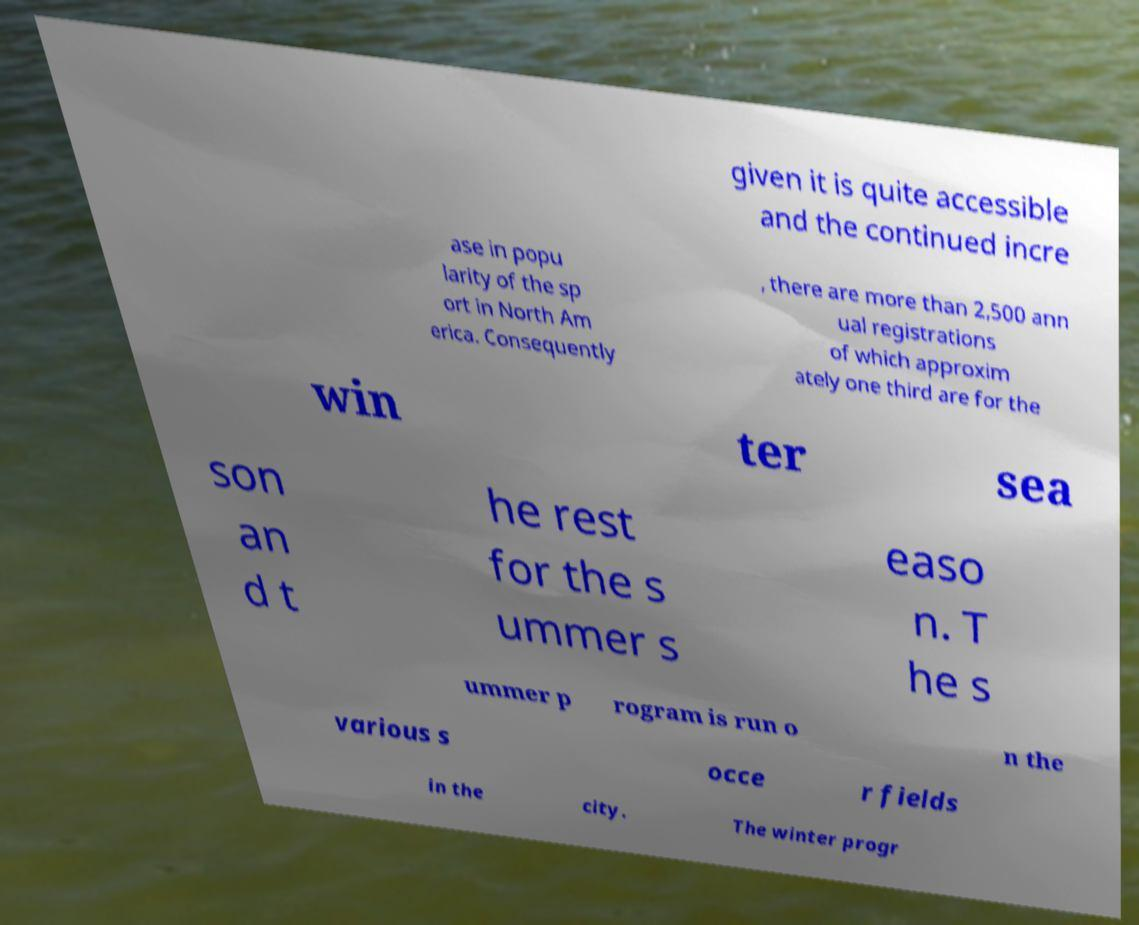Could you assist in decoding the text presented in this image and type it out clearly? given it is quite accessible and the continued incre ase in popu larity of the sp ort in North Am erica. Consequently , there are more than 2,500 ann ual registrations of which approxim ately one third are for the win ter sea son an d t he rest for the s ummer s easo n. T he s ummer p rogram is run o n the various s occe r fields in the city. The winter progr 